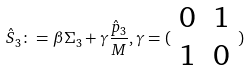Convert formula to latex. <formula><loc_0><loc_0><loc_500><loc_500>\hat { S } _ { 3 } \colon = \beta \Sigma _ { 3 } + \gamma \frac { \hat { p } _ { 3 } } { M } , \gamma = ( \begin{array} { c c } 0 & 1 \\ 1 & 0 \end{array} )</formula> 